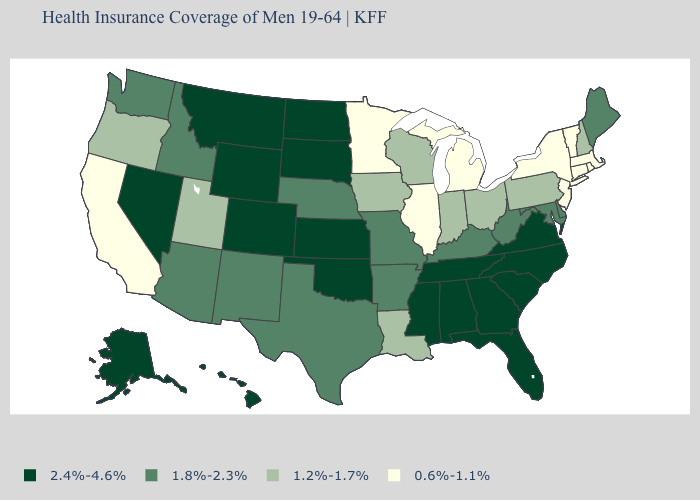What is the lowest value in the USA?
Quick response, please. 0.6%-1.1%. Does Louisiana have the highest value in the South?
Short answer required. No. What is the lowest value in the USA?
Short answer required. 0.6%-1.1%. Among the states that border Vermont , which have the highest value?
Give a very brief answer. New Hampshire. Name the states that have a value in the range 1.2%-1.7%?
Short answer required. Indiana, Iowa, Louisiana, New Hampshire, Ohio, Oregon, Pennsylvania, Utah, Wisconsin. Is the legend a continuous bar?
Short answer required. No. How many symbols are there in the legend?
Keep it brief. 4. Does Texas have the same value as West Virginia?
Short answer required. Yes. Does Wisconsin have the highest value in the USA?
Answer briefly. No. What is the value of Texas?
Short answer required. 1.8%-2.3%. Is the legend a continuous bar?
Be succinct. No. Name the states that have a value in the range 1.2%-1.7%?
Give a very brief answer. Indiana, Iowa, Louisiana, New Hampshire, Ohio, Oregon, Pennsylvania, Utah, Wisconsin. What is the value of Oklahoma?
Concise answer only. 2.4%-4.6%. Among the states that border California , does Oregon have the highest value?
Quick response, please. No. 